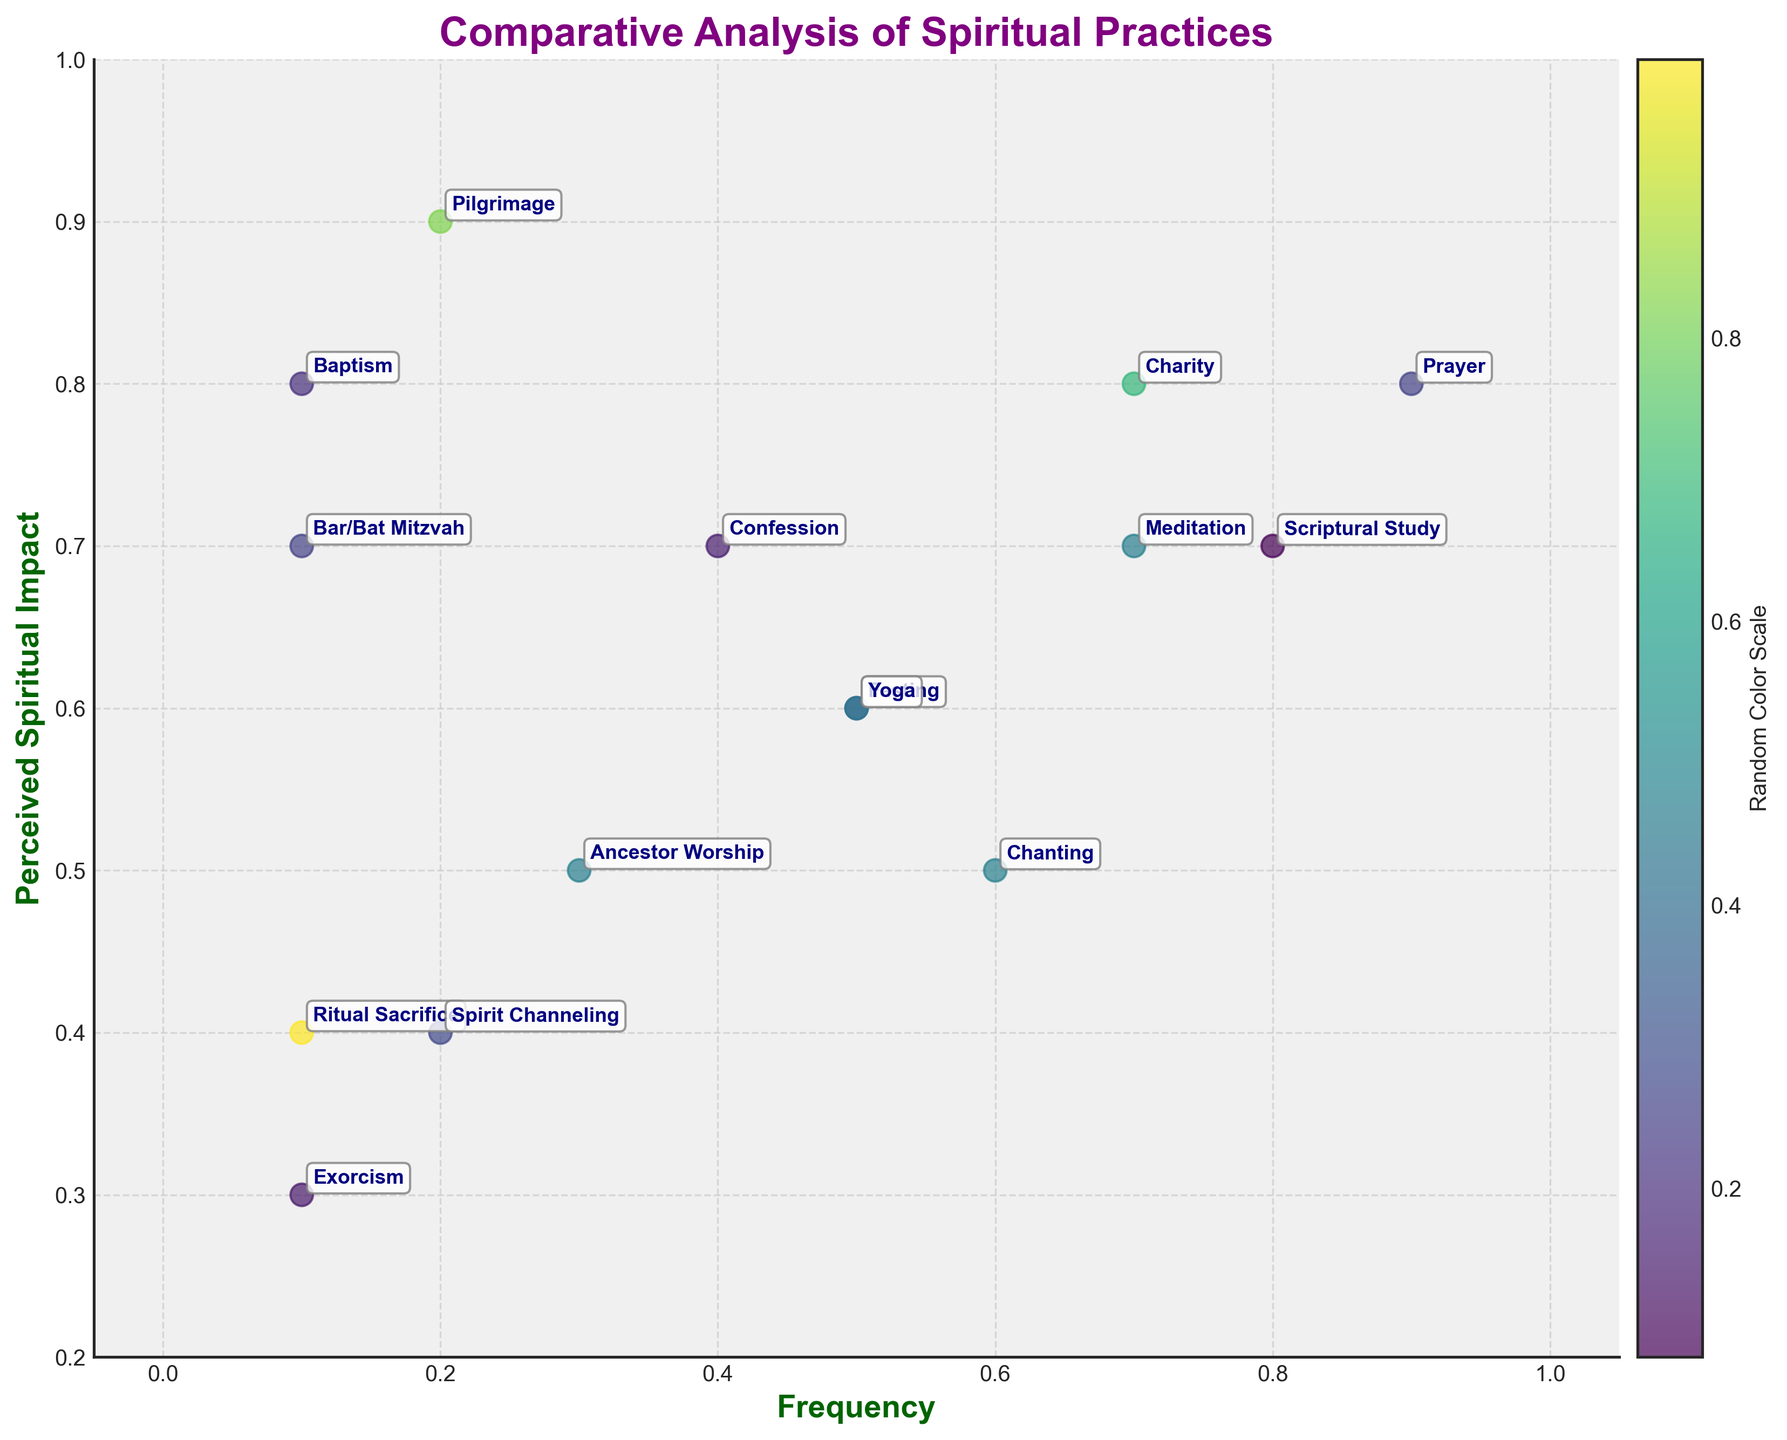What is the title of the figure? The title can be found at the top of the figure. It is a clear, concise description of what the figure represents.
Answer: "Comparative Analysis of Spiritual Practices" What are the labels of the x-axis and y-axis? The x-axis label and y-axis label are the descriptions found next to each axis. They provide information on what each axis measures.
Answer: The x-axis is labeled "Frequency" and the y-axis is labeled "Perceived Spiritual Impact" Which spiritual practice has the highest perceived spiritual impact? By examining the y-axis values, you can see that "Pilgrimage" reaches the highest point on this axis.
Answer: Pilgrimage How many data points have both frequency and perceived spiritual impact greater than 0.7? Find points where x > 0.7 and y > 0.7. There are two such points: "Prayer" (0.9, 0.8) and "Charity" (0.7, 0.8).
Answer: 2 Which practice has the lowest frequency and what is its perceived spiritual impact? Identify the point with the smallest x-value; "Ritual Sacrifice" has the lowest frequency of 0.1. The corresponding y-value is 0.4.
Answer: Ritual Sacrifice, 0.4 What is the average perceived spiritual impact of practices with a frequency of at least 0.5? Practices that qualify: "Prayer" (0.8), "Meditation" (0.7), "Chanting" (0.5), "Yoga" (0.6), "Scriptural Study" (0.7), and "Charity" (0.8). Sum the y-values: 4.1, then divide by 6.
Answer: (0.8 + 0.7 + 0.5 + 0.6 + 0.7 + 0.8) / 6 = 0.683 Which spiritual practice is closer to the origin (0,0) when compared between "Ancestor Worship" and "Confession"? Calculate the Euclidean distance for both: "Ancestor Worship" is √(0.3² + 0.5²) ≈ 0.583, "Confession" is √(0.4² + 0.7²) ≈ 0.806. "Ancestor Worship" is closer.
Answer: Ancestor Worship Which practices have the color legend indicating the value closest to 1 on the color scale? From the provided color scheme, identify practices with the most intense color saturation.
Answer: It requires visual inspection of the color bar, typically not directly answerable without accessing the figure What is the difference in perceived spiritual impact between the practice with the highest and the lowest frequency? "Prayer" (highest frequency 0.9) has an impact of 0.8; "Ritual Sacrifice" (lowest frequency 0.1) has an impact of 0.4. Calculate the difference: 0.8 - 0.4.
Answer: 0.4 Which practices have both frequency and perceived spiritual impact values exactly 0.1 apart from each other? Compare practices’ x and y differences; "Baptism" (0.1, 0.8) and "Bar/Bat Mitzvah" (0.1, 0.7) meet this criteria with differences in y-values as 0.1 apart from their x-values.
Answer: None 